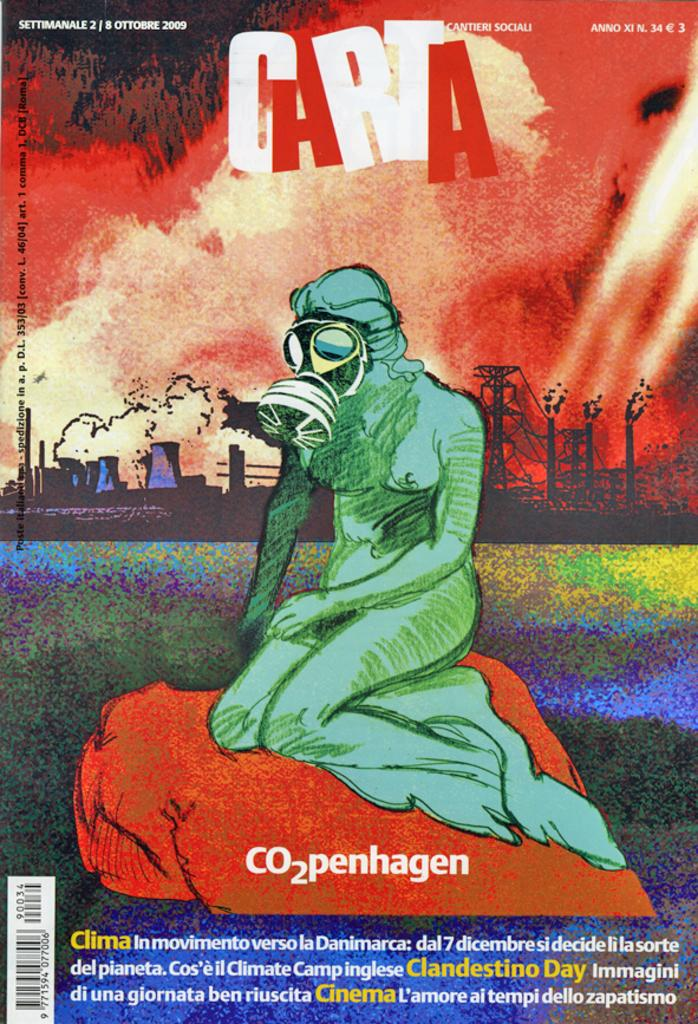<image>
Share a concise interpretation of the image provided. The cover of a magazine called carta with an illustration of a woman in a gas mask. 